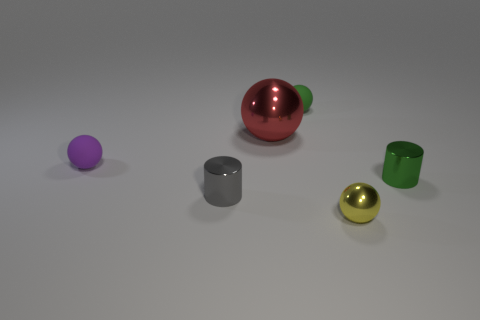Add 3 cylinders. How many objects exist? 9 Subtract all balls. How many objects are left? 2 Add 2 rubber balls. How many rubber balls are left? 4 Add 4 big green metal balls. How many big green metal balls exist? 4 Subtract 0 gray cubes. How many objects are left? 6 Subtract all large blue rubber cylinders. Subtract all yellow metallic spheres. How many objects are left? 5 